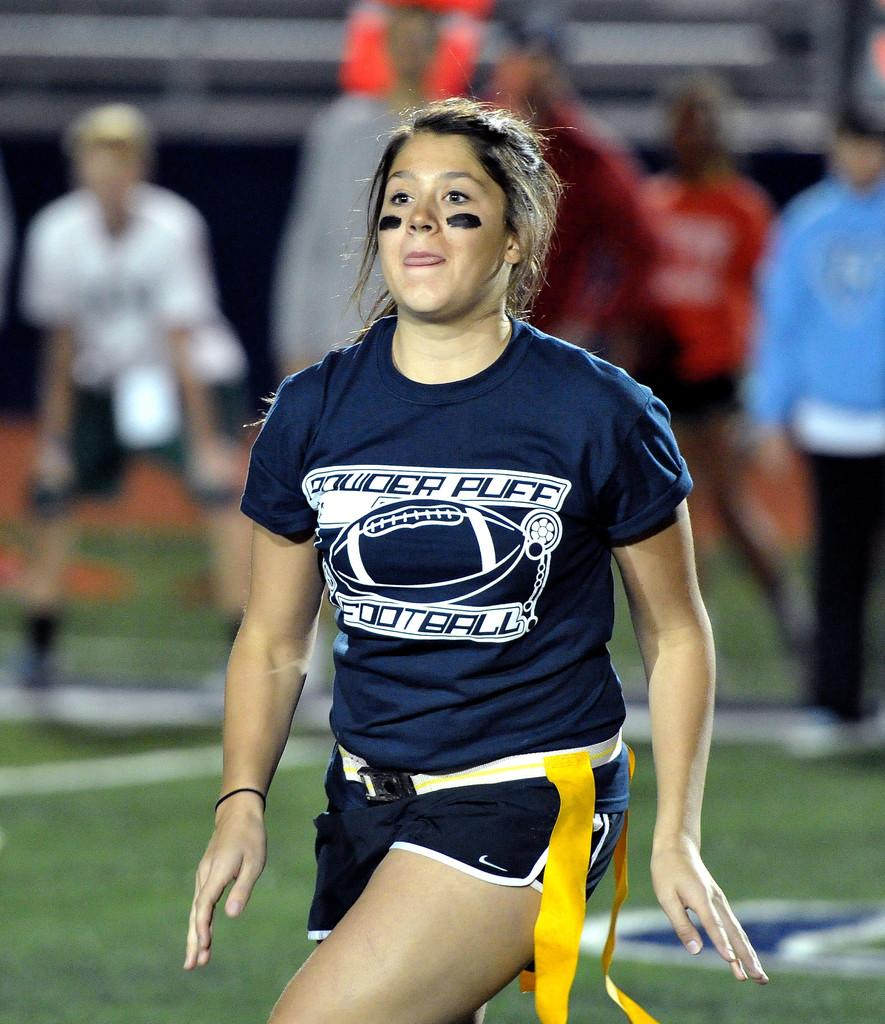<image>
Describe the image concisely. Young woman getting ready to catch the football in a power puff game. 